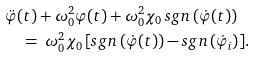Convert formula to latex. <formula><loc_0><loc_0><loc_500><loc_500>& \ddot { \varphi } ( t ) + \omega ^ { 2 } _ { 0 } \varphi ( t ) + \omega ^ { 2 } _ { 0 } \chi _ { 0 } \, s g n \left ( \dot { \varphi } ( t ) \right ) \\ & \quad = \ \omega ^ { 2 } _ { 0 } \chi _ { 0 } \, [ s g n \left ( \dot { \varphi } ( t ) \right ) - s g n \left ( \dot { \varphi } _ { i } \right ) ] .</formula> 